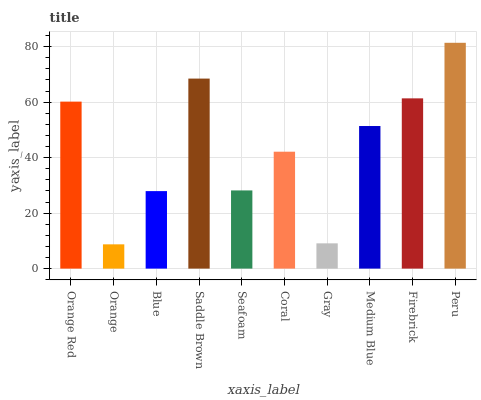Is Orange the minimum?
Answer yes or no. Yes. Is Peru the maximum?
Answer yes or no. Yes. Is Blue the minimum?
Answer yes or no. No. Is Blue the maximum?
Answer yes or no. No. Is Blue greater than Orange?
Answer yes or no. Yes. Is Orange less than Blue?
Answer yes or no. Yes. Is Orange greater than Blue?
Answer yes or no. No. Is Blue less than Orange?
Answer yes or no. No. Is Medium Blue the high median?
Answer yes or no. Yes. Is Coral the low median?
Answer yes or no. Yes. Is Coral the high median?
Answer yes or no. No. Is Seafoam the low median?
Answer yes or no. No. 